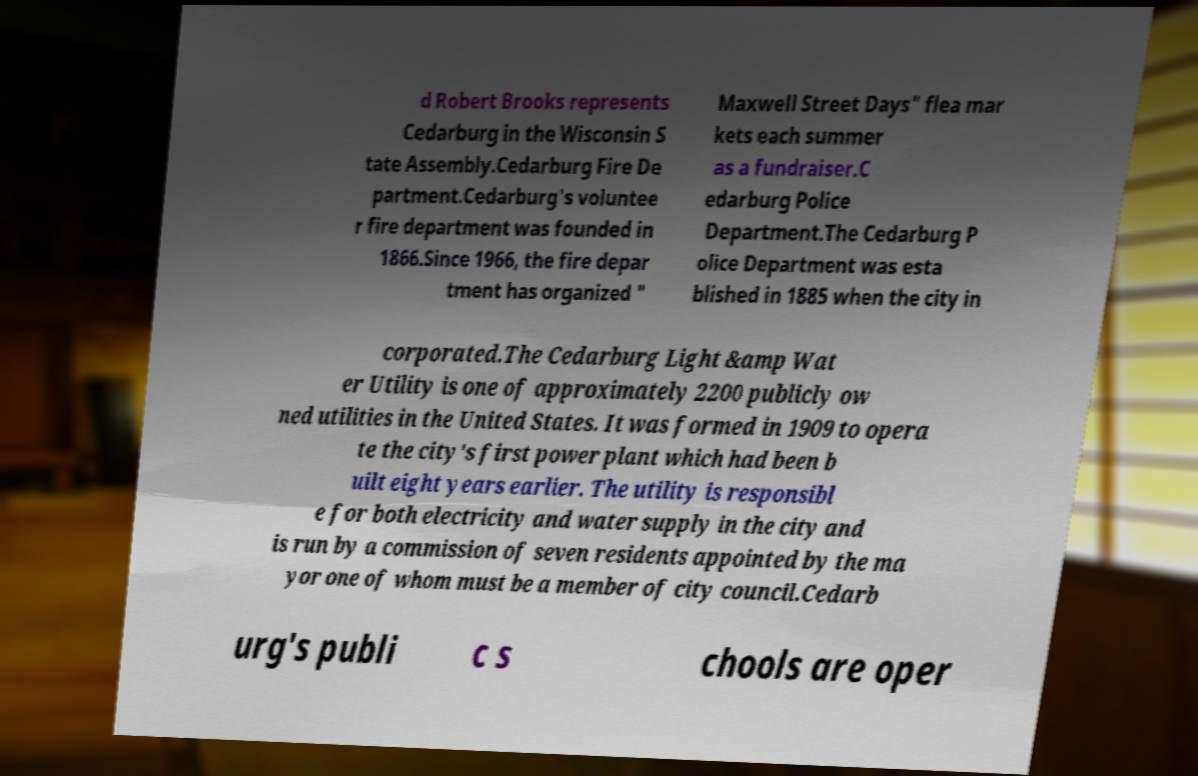There's text embedded in this image that I need extracted. Can you transcribe it verbatim? d Robert Brooks represents Cedarburg in the Wisconsin S tate Assembly.Cedarburg Fire De partment.Cedarburg's voluntee r fire department was founded in 1866.Since 1966, the fire depar tment has organized " Maxwell Street Days" flea mar kets each summer as a fundraiser.C edarburg Police Department.The Cedarburg P olice Department was esta blished in 1885 when the city in corporated.The Cedarburg Light &amp Wat er Utility is one of approximately 2200 publicly ow ned utilities in the United States. It was formed in 1909 to opera te the city's first power plant which had been b uilt eight years earlier. The utility is responsibl e for both electricity and water supply in the city and is run by a commission of seven residents appointed by the ma yor one of whom must be a member of city council.Cedarb urg's publi c s chools are oper 